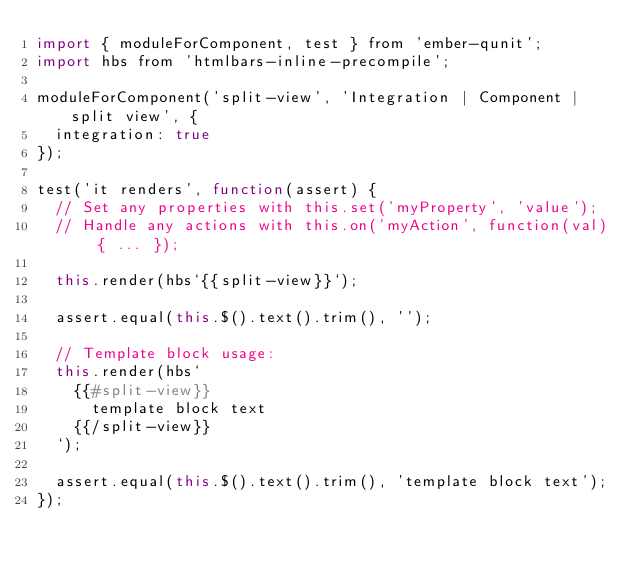Convert code to text. <code><loc_0><loc_0><loc_500><loc_500><_JavaScript_>import { moduleForComponent, test } from 'ember-qunit';
import hbs from 'htmlbars-inline-precompile';

moduleForComponent('split-view', 'Integration | Component | split view', {
  integration: true
});

test('it renders', function(assert) {
  // Set any properties with this.set('myProperty', 'value');
  // Handle any actions with this.on('myAction', function(val) { ... });

  this.render(hbs`{{split-view}}`);

  assert.equal(this.$().text().trim(), '');

  // Template block usage:
  this.render(hbs`
    {{#split-view}}
      template block text
    {{/split-view}}
  `);

  assert.equal(this.$().text().trim(), 'template block text');
});
</code> 